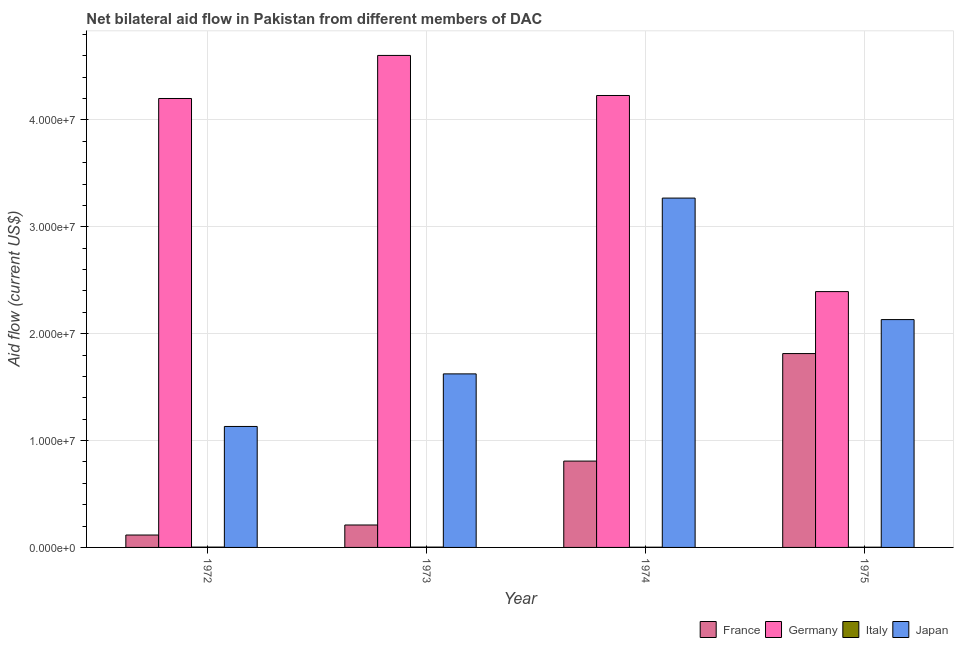Are the number of bars per tick equal to the number of legend labels?
Your answer should be very brief. Yes. How many bars are there on the 1st tick from the left?
Ensure brevity in your answer.  4. What is the label of the 3rd group of bars from the left?
Provide a succinct answer. 1974. What is the amount of aid given by france in 1973?
Make the answer very short. 2.10e+06. Across all years, what is the maximum amount of aid given by germany?
Offer a terse response. 4.60e+07. Across all years, what is the minimum amount of aid given by france?
Offer a very short reply. 1.16e+06. In which year was the amount of aid given by italy maximum?
Provide a short and direct response. 1972. In which year was the amount of aid given by italy minimum?
Your answer should be compact. 1974. What is the total amount of aid given by france in the graph?
Make the answer very short. 2.95e+07. What is the difference between the amount of aid given by france in 1973 and that in 1974?
Provide a succinct answer. -5.98e+06. What is the difference between the amount of aid given by japan in 1972 and the amount of aid given by italy in 1973?
Give a very brief answer. -4.92e+06. What is the average amount of aid given by japan per year?
Keep it short and to the point. 2.04e+07. In how many years, is the amount of aid given by germany greater than 22000000 US$?
Your answer should be very brief. 4. What is the ratio of the amount of aid given by germany in 1973 to that in 1975?
Your answer should be compact. 1.92. What is the difference between the highest and the second highest amount of aid given by japan?
Provide a succinct answer. 1.14e+07. What is the difference between the highest and the lowest amount of aid given by germany?
Your response must be concise. 2.21e+07. In how many years, is the amount of aid given by france greater than the average amount of aid given by france taken over all years?
Your response must be concise. 2. Is the sum of the amount of aid given by germany in 1972 and 1975 greater than the maximum amount of aid given by italy across all years?
Your answer should be very brief. Yes. What does the 1st bar from the left in 1973 represents?
Your answer should be very brief. France. How many bars are there?
Provide a short and direct response. 16. How many years are there in the graph?
Keep it short and to the point. 4. What is the difference between two consecutive major ticks on the Y-axis?
Your answer should be very brief. 1.00e+07. Does the graph contain grids?
Provide a succinct answer. Yes. What is the title of the graph?
Give a very brief answer. Net bilateral aid flow in Pakistan from different members of DAC. Does "Arable land" appear as one of the legend labels in the graph?
Provide a short and direct response. No. What is the label or title of the Y-axis?
Offer a terse response. Aid flow (current US$). What is the Aid flow (current US$) in France in 1972?
Ensure brevity in your answer.  1.16e+06. What is the Aid flow (current US$) in Germany in 1972?
Your answer should be compact. 4.20e+07. What is the Aid flow (current US$) of Japan in 1972?
Give a very brief answer. 1.13e+07. What is the Aid flow (current US$) of France in 1973?
Your answer should be very brief. 2.10e+06. What is the Aid flow (current US$) in Germany in 1973?
Make the answer very short. 4.60e+07. What is the Aid flow (current US$) of Japan in 1973?
Your answer should be compact. 1.62e+07. What is the Aid flow (current US$) of France in 1974?
Provide a succinct answer. 8.08e+06. What is the Aid flow (current US$) in Germany in 1974?
Ensure brevity in your answer.  4.23e+07. What is the Aid flow (current US$) in Italy in 1974?
Keep it short and to the point. 2.00e+04. What is the Aid flow (current US$) of Japan in 1974?
Your response must be concise. 3.27e+07. What is the Aid flow (current US$) of France in 1975?
Give a very brief answer. 1.81e+07. What is the Aid flow (current US$) of Germany in 1975?
Offer a very short reply. 2.39e+07. What is the Aid flow (current US$) in Italy in 1975?
Offer a terse response. 2.00e+04. What is the Aid flow (current US$) of Japan in 1975?
Keep it short and to the point. 2.13e+07. Across all years, what is the maximum Aid flow (current US$) in France?
Offer a very short reply. 1.81e+07. Across all years, what is the maximum Aid flow (current US$) of Germany?
Provide a succinct answer. 4.60e+07. Across all years, what is the maximum Aid flow (current US$) in Japan?
Your answer should be compact. 3.27e+07. Across all years, what is the minimum Aid flow (current US$) of France?
Keep it short and to the point. 1.16e+06. Across all years, what is the minimum Aid flow (current US$) of Germany?
Provide a succinct answer. 2.39e+07. Across all years, what is the minimum Aid flow (current US$) in Italy?
Offer a very short reply. 2.00e+04. Across all years, what is the minimum Aid flow (current US$) of Japan?
Your answer should be very brief. 1.13e+07. What is the total Aid flow (current US$) of France in the graph?
Provide a short and direct response. 2.95e+07. What is the total Aid flow (current US$) of Germany in the graph?
Your response must be concise. 1.54e+08. What is the total Aid flow (current US$) of Italy in the graph?
Offer a very short reply. 1.00e+05. What is the total Aid flow (current US$) of Japan in the graph?
Keep it short and to the point. 8.16e+07. What is the difference between the Aid flow (current US$) in France in 1972 and that in 1973?
Your answer should be compact. -9.40e+05. What is the difference between the Aid flow (current US$) in Germany in 1972 and that in 1973?
Your answer should be very brief. -4.03e+06. What is the difference between the Aid flow (current US$) in Japan in 1972 and that in 1973?
Ensure brevity in your answer.  -4.92e+06. What is the difference between the Aid flow (current US$) in France in 1972 and that in 1974?
Provide a short and direct response. -6.92e+06. What is the difference between the Aid flow (current US$) in Germany in 1972 and that in 1974?
Provide a short and direct response. -2.80e+05. What is the difference between the Aid flow (current US$) in Japan in 1972 and that in 1974?
Offer a terse response. -2.14e+07. What is the difference between the Aid flow (current US$) in France in 1972 and that in 1975?
Your answer should be compact. -1.70e+07. What is the difference between the Aid flow (current US$) of Germany in 1972 and that in 1975?
Offer a terse response. 1.81e+07. What is the difference between the Aid flow (current US$) in Japan in 1972 and that in 1975?
Ensure brevity in your answer.  -1.00e+07. What is the difference between the Aid flow (current US$) in France in 1973 and that in 1974?
Ensure brevity in your answer.  -5.98e+06. What is the difference between the Aid flow (current US$) in Germany in 1973 and that in 1974?
Ensure brevity in your answer.  3.75e+06. What is the difference between the Aid flow (current US$) in Japan in 1973 and that in 1974?
Make the answer very short. -1.64e+07. What is the difference between the Aid flow (current US$) of France in 1973 and that in 1975?
Offer a terse response. -1.60e+07. What is the difference between the Aid flow (current US$) of Germany in 1973 and that in 1975?
Your answer should be compact. 2.21e+07. What is the difference between the Aid flow (current US$) in Italy in 1973 and that in 1975?
Make the answer very short. 10000. What is the difference between the Aid flow (current US$) in Japan in 1973 and that in 1975?
Give a very brief answer. -5.08e+06. What is the difference between the Aid flow (current US$) in France in 1974 and that in 1975?
Ensure brevity in your answer.  -1.01e+07. What is the difference between the Aid flow (current US$) of Germany in 1974 and that in 1975?
Make the answer very short. 1.84e+07. What is the difference between the Aid flow (current US$) in Japan in 1974 and that in 1975?
Provide a succinct answer. 1.14e+07. What is the difference between the Aid flow (current US$) of France in 1972 and the Aid flow (current US$) of Germany in 1973?
Keep it short and to the point. -4.49e+07. What is the difference between the Aid flow (current US$) in France in 1972 and the Aid flow (current US$) in Italy in 1973?
Offer a terse response. 1.13e+06. What is the difference between the Aid flow (current US$) in France in 1972 and the Aid flow (current US$) in Japan in 1973?
Make the answer very short. -1.51e+07. What is the difference between the Aid flow (current US$) in Germany in 1972 and the Aid flow (current US$) in Italy in 1973?
Give a very brief answer. 4.20e+07. What is the difference between the Aid flow (current US$) in Germany in 1972 and the Aid flow (current US$) in Japan in 1973?
Your answer should be very brief. 2.58e+07. What is the difference between the Aid flow (current US$) in Italy in 1972 and the Aid flow (current US$) in Japan in 1973?
Make the answer very short. -1.62e+07. What is the difference between the Aid flow (current US$) in France in 1972 and the Aid flow (current US$) in Germany in 1974?
Offer a terse response. -4.11e+07. What is the difference between the Aid flow (current US$) in France in 1972 and the Aid flow (current US$) in Italy in 1974?
Your answer should be compact. 1.14e+06. What is the difference between the Aid flow (current US$) in France in 1972 and the Aid flow (current US$) in Japan in 1974?
Offer a terse response. -3.15e+07. What is the difference between the Aid flow (current US$) of Germany in 1972 and the Aid flow (current US$) of Italy in 1974?
Ensure brevity in your answer.  4.20e+07. What is the difference between the Aid flow (current US$) in Germany in 1972 and the Aid flow (current US$) in Japan in 1974?
Ensure brevity in your answer.  9.32e+06. What is the difference between the Aid flow (current US$) in Italy in 1972 and the Aid flow (current US$) in Japan in 1974?
Offer a terse response. -3.27e+07. What is the difference between the Aid flow (current US$) of France in 1972 and the Aid flow (current US$) of Germany in 1975?
Your answer should be very brief. -2.28e+07. What is the difference between the Aid flow (current US$) in France in 1972 and the Aid flow (current US$) in Italy in 1975?
Your answer should be very brief. 1.14e+06. What is the difference between the Aid flow (current US$) of France in 1972 and the Aid flow (current US$) of Japan in 1975?
Ensure brevity in your answer.  -2.02e+07. What is the difference between the Aid flow (current US$) in Germany in 1972 and the Aid flow (current US$) in Italy in 1975?
Provide a short and direct response. 4.20e+07. What is the difference between the Aid flow (current US$) in Germany in 1972 and the Aid flow (current US$) in Japan in 1975?
Provide a succinct answer. 2.07e+07. What is the difference between the Aid flow (current US$) of Italy in 1972 and the Aid flow (current US$) of Japan in 1975?
Your response must be concise. -2.13e+07. What is the difference between the Aid flow (current US$) of France in 1973 and the Aid flow (current US$) of Germany in 1974?
Offer a very short reply. -4.02e+07. What is the difference between the Aid flow (current US$) of France in 1973 and the Aid flow (current US$) of Italy in 1974?
Offer a terse response. 2.08e+06. What is the difference between the Aid flow (current US$) in France in 1973 and the Aid flow (current US$) in Japan in 1974?
Your response must be concise. -3.06e+07. What is the difference between the Aid flow (current US$) of Germany in 1973 and the Aid flow (current US$) of Italy in 1974?
Offer a terse response. 4.60e+07. What is the difference between the Aid flow (current US$) in Germany in 1973 and the Aid flow (current US$) in Japan in 1974?
Your response must be concise. 1.34e+07. What is the difference between the Aid flow (current US$) in Italy in 1973 and the Aid flow (current US$) in Japan in 1974?
Your answer should be very brief. -3.27e+07. What is the difference between the Aid flow (current US$) in France in 1973 and the Aid flow (current US$) in Germany in 1975?
Your response must be concise. -2.18e+07. What is the difference between the Aid flow (current US$) of France in 1973 and the Aid flow (current US$) of Italy in 1975?
Provide a short and direct response. 2.08e+06. What is the difference between the Aid flow (current US$) in France in 1973 and the Aid flow (current US$) in Japan in 1975?
Offer a very short reply. -1.92e+07. What is the difference between the Aid flow (current US$) in Germany in 1973 and the Aid flow (current US$) in Italy in 1975?
Ensure brevity in your answer.  4.60e+07. What is the difference between the Aid flow (current US$) of Germany in 1973 and the Aid flow (current US$) of Japan in 1975?
Make the answer very short. 2.47e+07. What is the difference between the Aid flow (current US$) in Italy in 1973 and the Aid flow (current US$) in Japan in 1975?
Offer a very short reply. -2.13e+07. What is the difference between the Aid flow (current US$) in France in 1974 and the Aid flow (current US$) in Germany in 1975?
Ensure brevity in your answer.  -1.59e+07. What is the difference between the Aid flow (current US$) of France in 1974 and the Aid flow (current US$) of Italy in 1975?
Provide a short and direct response. 8.06e+06. What is the difference between the Aid flow (current US$) of France in 1974 and the Aid flow (current US$) of Japan in 1975?
Offer a very short reply. -1.32e+07. What is the difference between the Aid flow (current US$) in Germany in 1974 and the Aid flow (current US$) in Italy in 1975?
Give a very brief answer. 4.23e+07. What is the difference between the Aid flow (current US$) in Germany in 1974 and the Aid flow (current US$) in Japan in 1975?
Your answer should be very brief. 2.10e+07. What is the difference between the Aid flow (current US$) of Italy in 1974 and the Aid flow (current US$) of Japan in 1975?
Your response must be concise. -2.13e+07. What is the average Aid flow (current US$) in France per year?
Provide a succinct answer. 7.37e+06. What is the average Aid flow (current US$) in Germany per year?
Your answer should be very brief. 3.86e+07. What is the average Aid flow (current US$) in Italy per year?
Make the answer very short. 2.50e+04. What is the average Aid flow (current US$) in Japan per year?
Ensure brevity in your answer.  2.04e+07. In the year 1972, what is the difference between the Aid flow (current US$) of France and Aid flow (current US$) of Germany?
Ensure brevity in your answer.  -4.08e+07. In the year 1972, what is the difference between the Aid flow (current US$) in France and Aid flow (current US$) in Italy?
Provide a succinct answer. 1.13e+06. In the year 1972, what is the difference between the Aid flow (current US$) in France and Aid flow (current US$) in Japan?
Provide a short and direct response. -1.02e+07. In the year 1972, what is the difference between the Aid flow (current US$) of Germany and Aid flow (current US$) of Italy?
Give a very brief answer. 4.20e+07. In the year 1972, what is the difference between the Aid flow (current US$) of Germany and Aid flow (current US$) of Japan?
Your answer should be compact. 3.07e+07. In the year 1972, what is the difference between the Aid flow (current US$) in Italy and Aid flow (current US$) in Japan?
Provide a succinct answer. -1.13e+07. In the year 1973, what is the difference between the Aid flow (current US$) of France and Aid flow (current US$) of Germany?
Keep it short and to the point. -4.39e+07. In the year 1973, what is the difference between the Aid flow (current US$) in France and Aid flow (current US$) in Italy?
Provide a short and direct response. 2.07e+06. In the year 1973, what is the difference between the Aid flow (current US$) of France and Aid flow (current US$) of Japan?
Give a very brief answer. -1.41e+07. In the year 1973, what is the difference between the Aid flow (current US$) of Germany and Aid flow (current US$) of Italy?
Offer a very short reply. 4.60e+07. In the year 1973, what is the difference between the Aid flow (current US$) of Germany and Aid flow (current US$) of Japan?
Give a very brief answer. 2.98e+07. In the year 1973, what is the difference between the Aid flow (current US$) in Italy and Aid flow (current US$) in Japan?
Provide a succinct answer. -1.62e+07. In the year 1974, what is the difference between the Aid flow (current US$) in France and Aid flow (current US$) in Germany?
Ensure brevity in your answer.  -3.42e+07. In the year 1974, what is the difference between the Aid flow (current US$) in France and Aid flow (current US$) in Italy?
Offer a very short reply. 8.06e+06. In the year 1974, what is the difference between the Aid flow (current US$) in France and Aid flow (current US$) in Japan?
Keep it short and to the point. -2.46e+07. In the year 1974, what is the difference between the Aid flow (current US$) in Germany and Aid flow (current US$) in Italy?
Your answer should be compact. 4.23e+07. In the year 1974, what is the difference between the Aid flow (current US$) in Germany and Aid flow (current US$) in Japan?
Offer a terse response. 9.60e+06. In the year 1974, what is the difference between the Aid flow (current US$) of Italy and Aid flow (current US$) of Japan?
Ensure brevity in your answer.  -3.27e+07. In the year 1975, what is the difference between the Aid flow (current US$) of France and Aid flow (current US$) of Germany?
Your answer should be very brief. -5.80e+06. In the year 1975, what is the difference between the Aid flow (current US$) of France and Aid flow (current US$) of Italy?
Give a very brief answer. 1.81e+07. In the year 1975, what is the difference between the Aid flow (current US$) in France and Aid flow (current US$) in Japan?
Provide a succinct answer. -3.18e+06. In the year 1975, what is the difference between the Aid flow (current US$) in Germany and Aid flow (current US$) in Italy?
Your answer should be very brief. 2.39e+07. In the year 1975, what is the difference between the Aid flow (current US$) in Germany and Aid flow (current US$) in Japan?
Your answer should be compact. 2.62e+06. In the year 1975, what is the difference between the Aid flow (current US$) of Italy and Aid flow (current US$) of Japan?
Offer a very short reply. -2.13e+07. What is the ratio of the Aid flow (current US$) of France in 1972 to that in 1973?
Offer a terse response. 0.55. What is the ratio of the Aid flow (current US$) in Germany in 1972 to that in 1973?
Offer a terse response. 0.91. What is the ratio of the Aid flow (current US$) of Italy in 1972 to that in 1973?
Your response must be concise. 1. What is the ratio of the Aid flow (current US$) in Japan in 1972 to that in 1973?
Provide a short and direct response. 0.7. What is the ratio of the Aid flow (current US$) of France in 1972 to that in 1974?
Keep it short and to the point. 0.14. What is the ratio of the Aid flow (current US$) in Germany in 1972 to that in 1974?
Offer a very short reply. 0.99. What is the ratio of the Aid flow (current US$) of Italy in 1972 to that in 1974?
Your answer should be compact. 1.5. What is the ratio of the Aid flow (current US$) of Japan in 1972 to that in 1974?
Make the answer very short. 0.35. What is the ratio of the Aid flow (current US$) of France in 1972 to that in 1975?
Ensure brevity in your answer.  0.06. What is the ratio of the Aid flow (current US$) in Germany in 1972 to that in 1975?
Keep it short and to the point. 1.75. What is the ratio of the Aid flow (current US$) of Japan in 1972 to that in 1975?
Ensure brevity in your answer.  0.53. What is the ratio of the Aid flow (current US$) in France in 1973 to that in 1974?
Ensure brevity in your answer.  0.26. What is the ratio of the Aid flow (current US$) of Germany in 1973 to that in 1974?
Offer a terse response. 1.09. What is the ratio of the Aid flow (current US$) of Japan in 1973 to that in 1974?
Your answer should be compact. 0.5. What is the ratio of the Aid flow (current US$) of France in 1973 to that in 1975?
Give a very brief answer. 0.12. What is the ratio of the Aid flow (current US$) in Germany in 1973 to that in 1975?
Provide a short and direct response. 1.92. What is the ratio of the Aid flow (current US$) of Japan in 1973 to that in 1975?
Your response must be concise. 0.76. What is the ratio of the Aid flow (current US$) of France in 1974 to that in 1975?
Offer a terse response. 0.45. What is the ratio of the Aid flow (current US$) in Germany in 1974 to that in 1975?
Your answer should be compact. 1.77. What is the ratio of the Aid flow (current US$) in Japan in 1974 to that in 1975?
Provide a succinct answer. 1.53. What is the difference between the highest and the second highest Aid flow (current US$) in France?
Your answer should be very brief. 1.01e+07. What is the difference between the highest and the second highest Aid flow (current US$) of Germany?
Ensure brevity in your answer.  3.75e+06. What is the difference between the highest and the second highest Aid flow (current US$) of Japan?
Provide a succinct answer. 1.14e+07. What is the difference between the highest and the lowest Aid flow (current US$) in France?
Offer a terse response. 1.70e+07. What is the difference between the highest and the lowest Aid flow (current US$) in Germany?
Provide a short and direct response. 2.21e+07. What is the difference between the highest and the lowest Aid flow (current US$) in Japan?
Keep it short and to the point. 2.14e+07. 